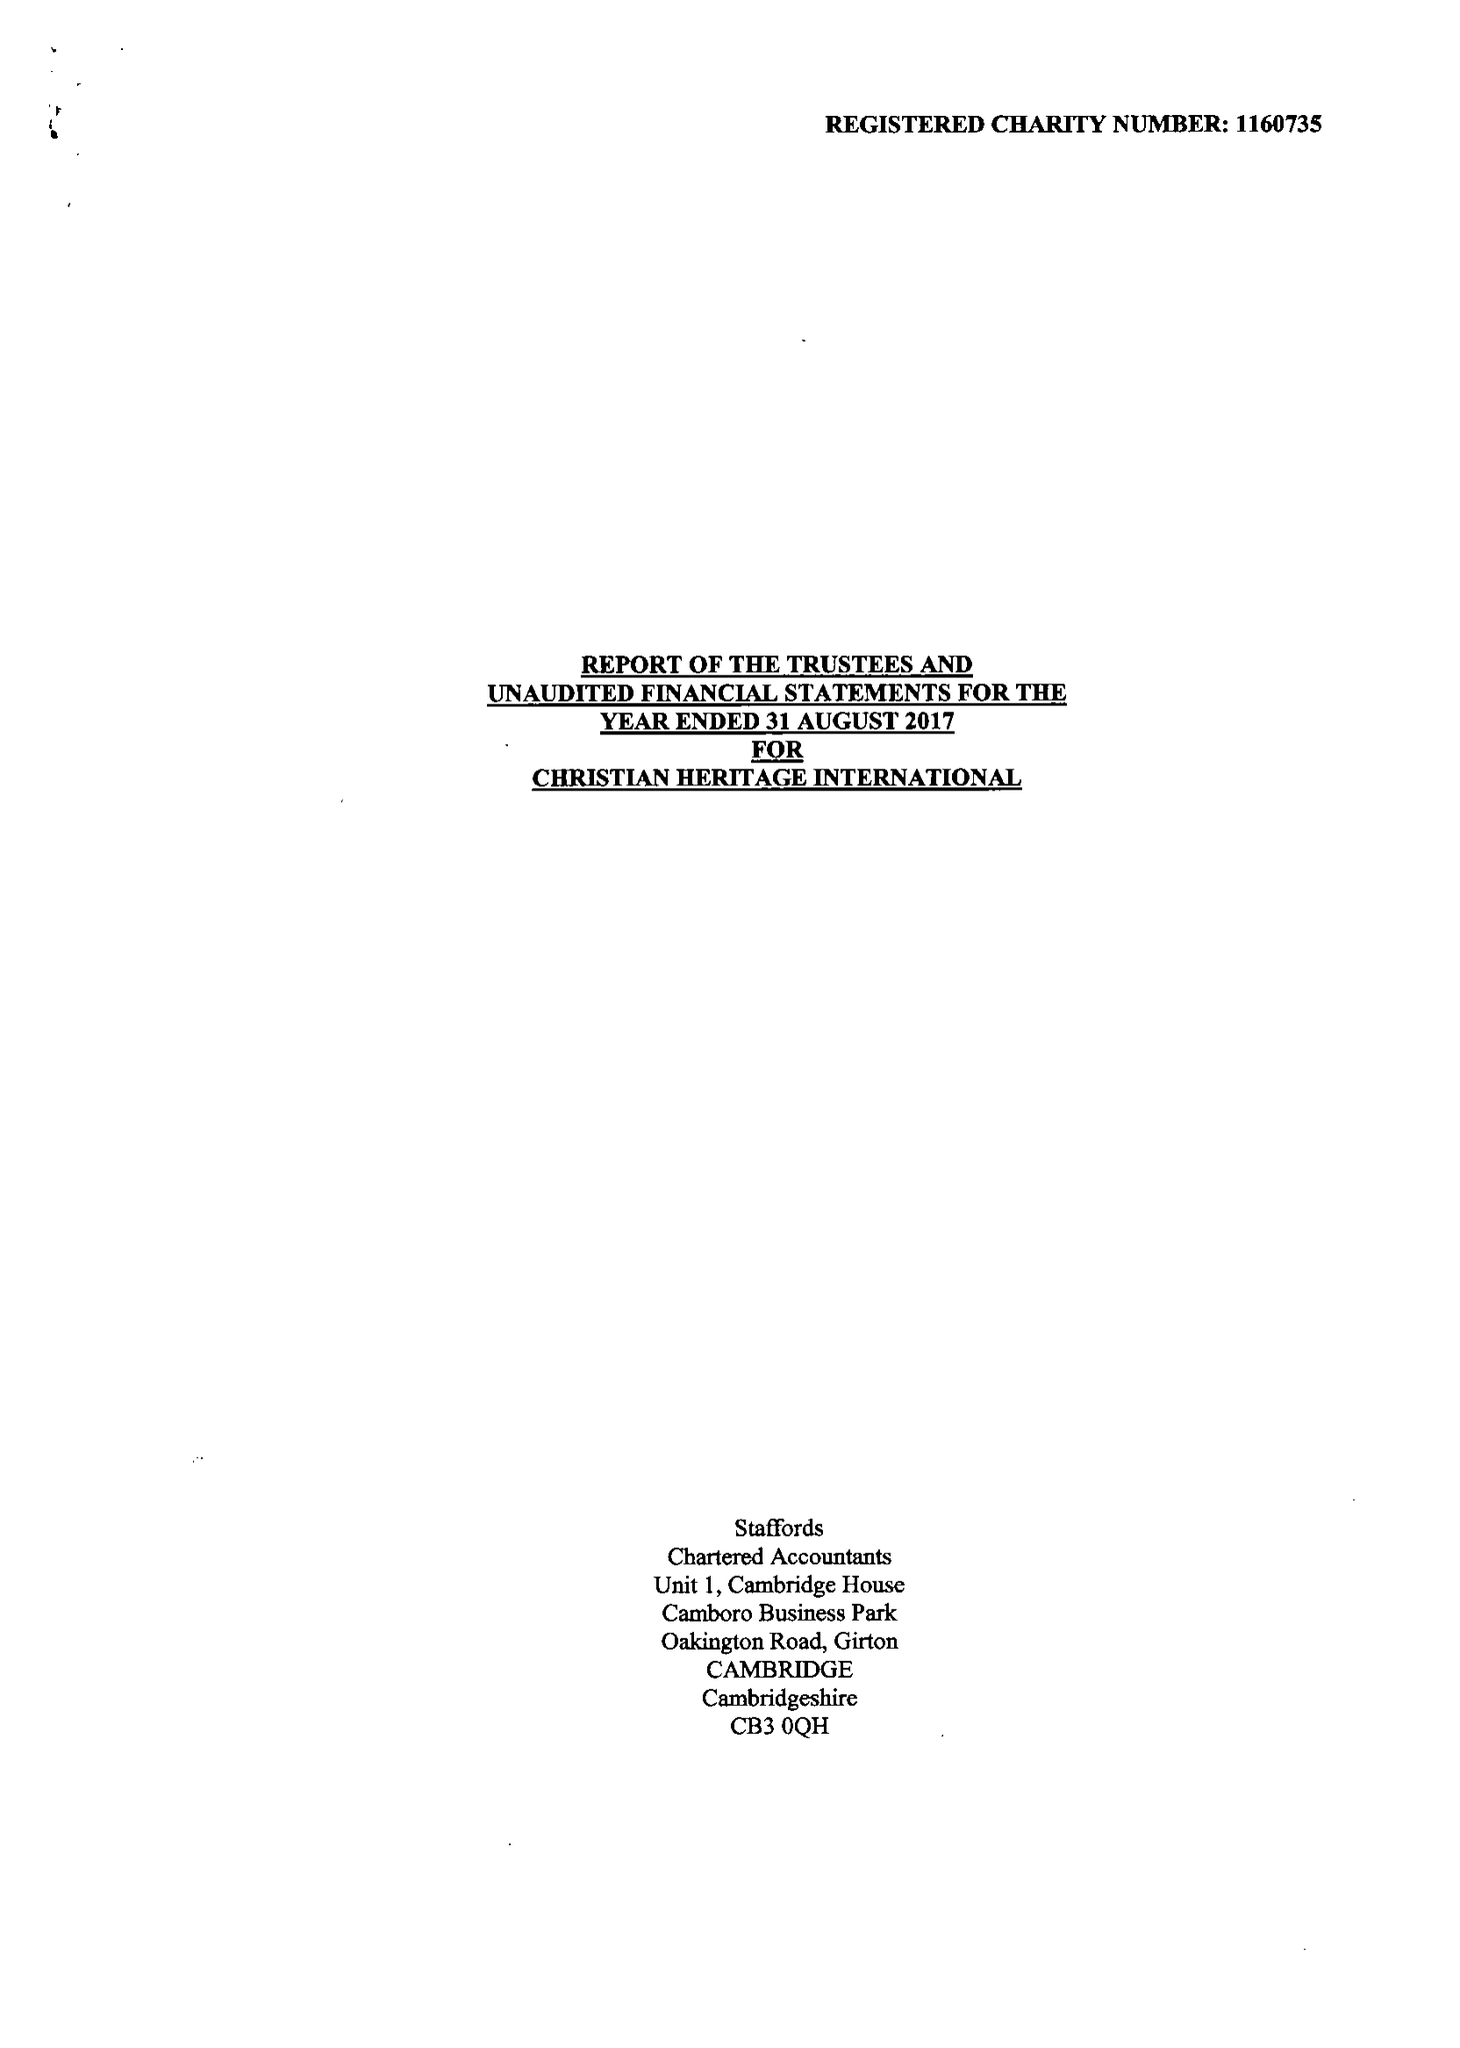What is the value for the report_date?
Answer the question using a single word or phrase. 2017-08-31 